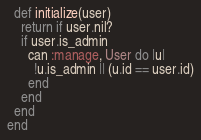Convert code to text. <code><loc_0><loc_0><loc_500><loc_500><_Ruby_>
  def initialize(user)
    return if user.nil?
    if user.is_admin
      can :manage, User do |u|
        !u.is_admin || (u.id == user.id)
      end
    end
  end
end
</code> 